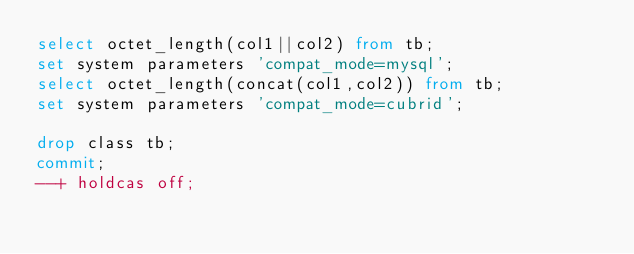Convert code to text. <code><loc_0><loc_0><loc_500><loc_500><_SQL_>select octet_length(col1||col2) from tb;
set system parameters 'compat_mode=mysql';
select octet_length(concat(col1,col2)) from tb;
set system parameters 'compat_mode=cubrid';
 
drop class tb;
commit;
--+ holdcas off;
</code> 